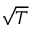<formula> <loc_0><loc_0><loc_500><loc_500>\sqrt { T }</formula> 